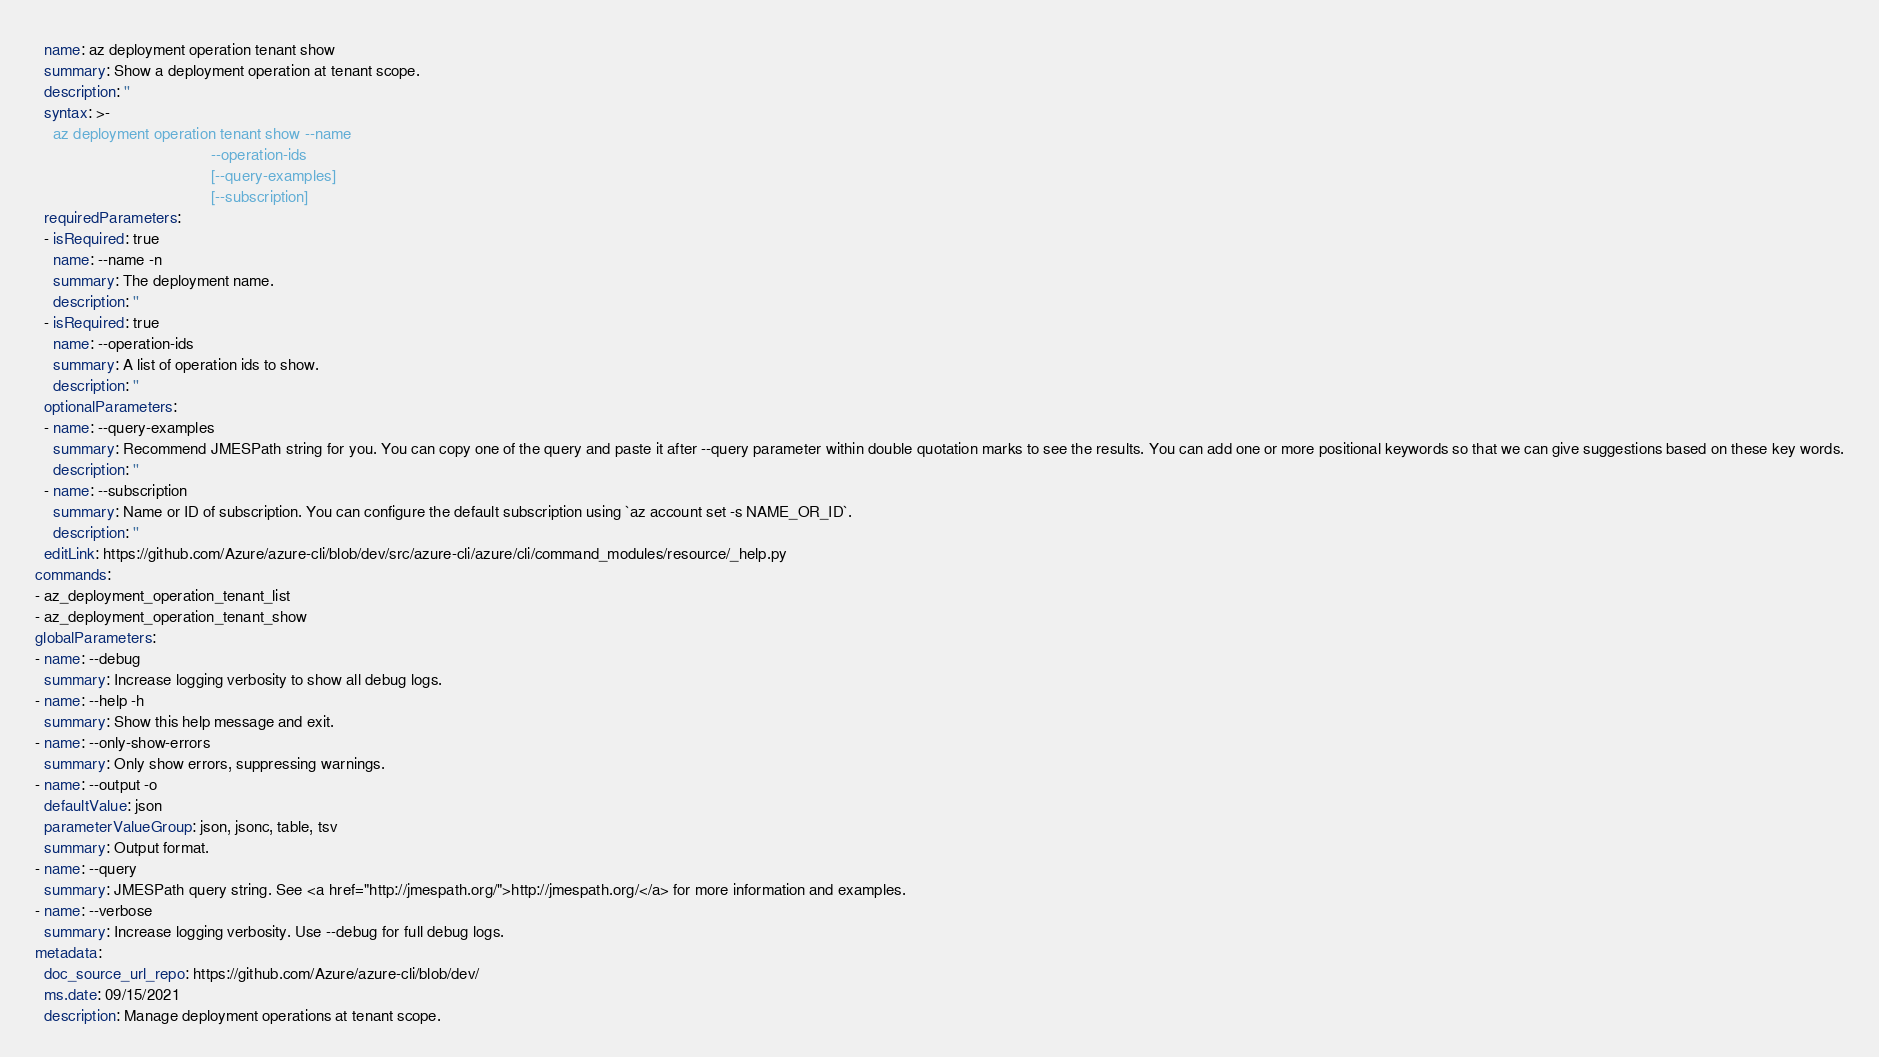<code> <loc_0><loc_0><loc_500><loc_500><_YAML_>  name: az deployment operation tenant show
  summary: Show a deployment operation at tenant scope.
  description: ''
  syntax: >-
    az deployment operation tenant show --name
                                        --operation-ids
                                        [--query-examples]
                                        [--subscription]
  requiredParameters:
  - isRequired: true
    name: --name -n
    summary: The deployment name.
    description: ''
  - isRequired: true
    name: --operation-ids
    summary: A list of operation ids to show.
    description: ''
  optionalParameters:
  - name: --query-examples
    summary: Recommend JMESPath string for you. You can copy one of the query and paste it after --query parameter within double quotation marks to see the results. You can add one or more positional keywords so that we can give suggestions based on these key words.
    description: ''
  - name: --subscription
    summary: Name or ID of subscription. You can configure the default subscription using `az account set -s NAME_OR_ID`.
    description: ''
  editLink: https://github.com/Azure/azure-cli/blob/dev/src/azure-cli/azure/cli/command_modules/resource/_help.py
commands:
- az_deployment_operation_tenant_list
- az_deployment_operation_tenant_show
globalParameters:
- name: --debug
  summary: Increase logging verbosity to show all debug logs.
- name: --help -h
  summary: Show this help message and exit.
- name: --only-show-errors
  summary: Only show errors, suppressing warnings.
- name: --output -o
  defaultValue: json
  parameterValueGroup: json, jsonc, table, tsv
  summary: Output format.
- name: --query
  summary: JMESPath query string. See <a href="http://jmespath.org/">http://jmespath.org/</a> for more information and examples.
- name: --verbose
  summary: Increase logging verbosity. Use --debug for full debug logs.
metadata:
  doc_source_url_repo: https://github.com/Azure/azure-cli/blob/dev/
  ms.date: 09/15/2021
  description: Manage deployment operations at tenant scope.
</code> 